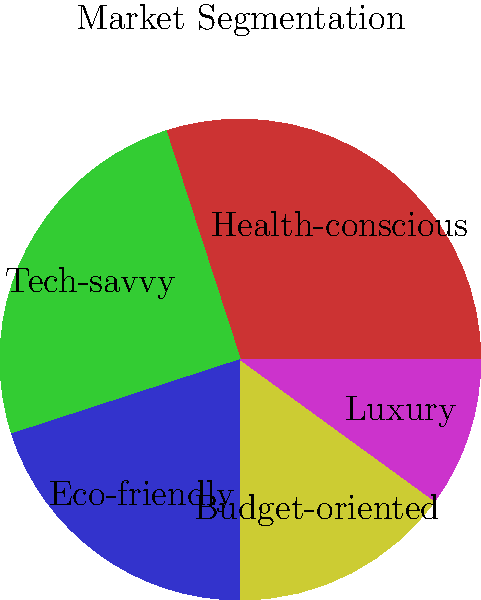As an entrepreneur targeting niche markets, you've conducted market research and segmented your potential customers into five categories as shown in the pie chart. If you decide to focus on the two largest segments initially, what percentage of the total market would you be targeting? To solve this problem, we need to follow these steps:

1. Identify the two largest segments in the pie chart:
   - Health-conscious: 30%
   - Tech-savvy: 25%

2. Add the percentages of these two segments:
   $30\% + 25\% = 55\%$

The calculation is straightforward:

$$\text{Total market share} = \text{Largest segment} + \text{Second largest segment}$$
$$\text{Total market share} = 30\% + 25\% = 55\%$$

By focusing on the health-conscious and tech-savvy segments, you would be targeting 55% of the total market.

This approach allows you to concentrate your resources on the most significant portions of the market, potentially maximizing your return on investment and increasing your chances of success in the initial stages of your business.
Answer: 55% 